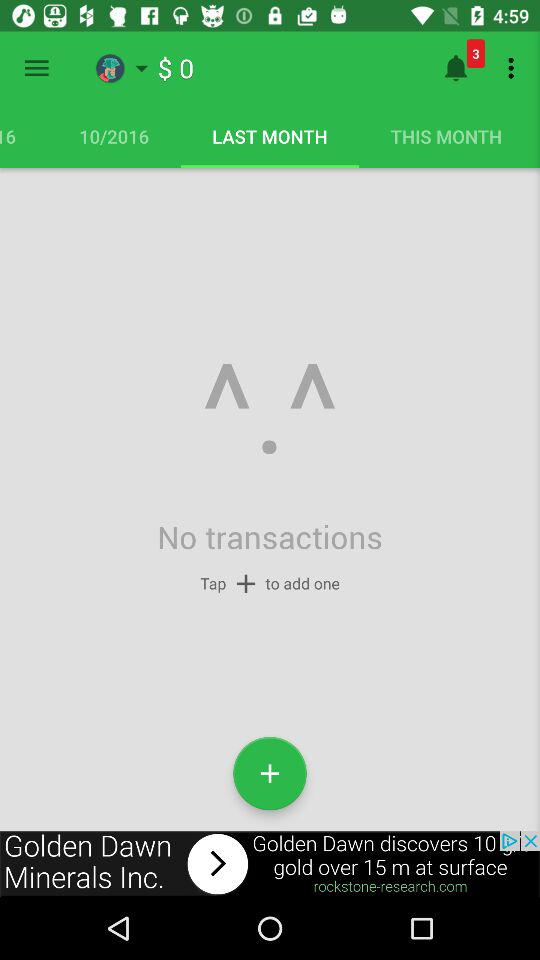How much money do I have in total?
Answer the question using a single word or phrase. $0 